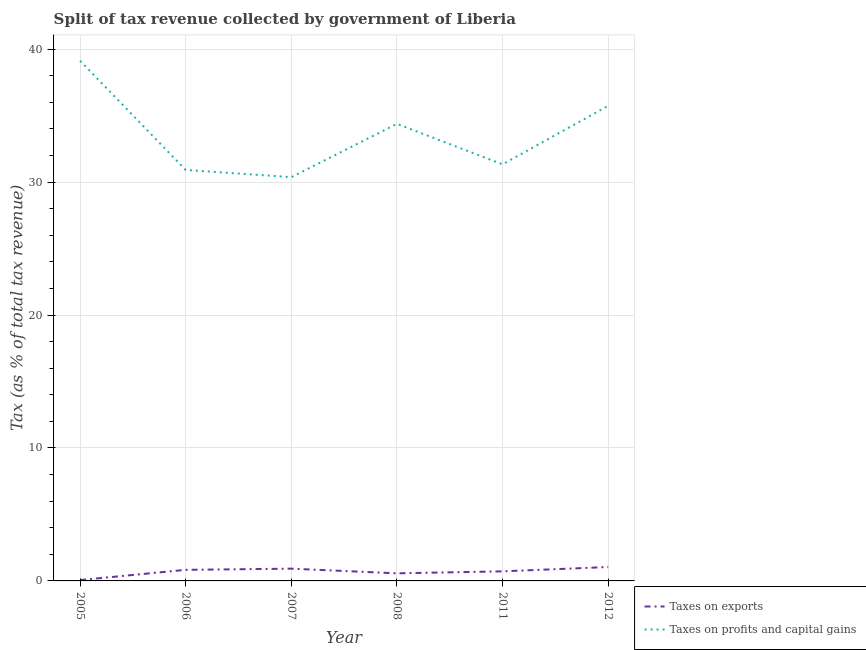How many different coloured lines are there?
Your response must be concise. 2. Is the number of lines equal to the number of legend labels?
Provide a short and direct response. Yes. What is the percentage of revenue obtained from taxes on exports in 2005?
Keep it short and to the point. 0.06. Across all years, what is the maximum percentage of revenue obtained from taxes on exports?
Offer a terse response. 1.05. Across all years, what is the minimum percentage of revenue obtained from taxes on exports?
Make the answer very short. 0.06. In which year was the percentage of revenue obtained from taxes on exports maximum?
Provide a succinct answer. 2012. In which year was the percentage of revenue obtained from taxes on exports minimum?
Ensure brevity in your answer.  2005. What is the total percentage of revenue obtained from taxes on exports in the graph?
Offer a terse response. 4.16. What is the difference between the percentage of revenue obtained from taxes on profits and capital gains in 2008 and that in 2011?
Your answer should be compact. 3.05. What is the difference between the percentage of revenue obtained from taxes on profits and capital gains in 2005 and the percentage of revenue obtained from taxes on exports in 2012?
Offer a very short reply. 38.08. What is the average percentage of revenue obtained from taxes on exports per year?
Your answer should be compact. 0.69. In the year 2005, what is the difference between the percentage of revenue obtained from taxes on profits and capital gains and percentage of revenue obtained from taxes on exports?
Provide a succinct answer. 39.06. What is the ratio of the percentage of revenue obtained from taxes on profits and capital gains in 2007 to that in 2012?
Your answer should be compact. 0.85. Is the percentage of revenue obtained from taxes on exports in 2007 less than that in 2008?
Offer a terse response. No. Is the difference between the percentage of revenue obtained from taxes on profits and capital gains in 2007 and 2011 greater than the difference between the percentage of revenue obtained from taxes on exports in 2007 and 2011?
Provide a short and direct response. No. What is the difference between the highest and the second highest percentage of revenue obtained from taxes on exports?
Ensure brevity in your answer.  0.12. What is the difference between the highest and the lowest percentage of revenue obtained from taxes on exports?
Your response must be concise. 0.98. In how many years, is the percentage of revenue obtained from taxes on profits and capital gains greater than the average percentage of revenue obtained from taxes on profits and capital gains taken over all years?
Offer a terse response. 3. Does the percentage of revenue obtained from taxes on profits and capital gains monotonically increase over the years?
Your answer should be very brief. No. Is the percentage of revenue obtained from taxes on exports strictly greater than the percentage of revenue obtained from taxes on profits and capital gains over the years?
Offer a very short reply. No. Is the percentage of revenue obtained from taxes on profits and capital gains strictly less than the percentage of revenue obtained from taxes on exports over the years?
Offer a very short reply. No. How many lines are there?
Keep it short and to the point. 2. Does the graph contain any zero values?
Provide a succinct answer. No. Does the graph contain grids?
Provide a short and direct response. Yes. Where does the legend appear in the graph?
Ensure brevity in your answer.  Bottom right. How many legend labels are there?
Provide a short and direct response. 2. How are the legend labels stacked?
Offer a very short reply. Vertical. What is the title of the graph?
Provide a succinct answer. Split of tax revenue collected by government of Liberia. Does "% of gross capital formation" appear as one of the legend labels in the graph?
Make the answer very short. No. What is the label or title of the X-axis?
Your answer should be very brief. Year. What is the label or title of the Y-axis?
Provide a succinct answer. Tax (as % of total tax revenue). What is the Tax (as % of total tax revenue) of Taxes on exports in 2005?
Ensure brevity in your answer.  0.06. What is the Tax (as % of total tax revenue) of Taxes on profits and capital gains in 2005?
Your answer should be compact. 39.13. What is the Tax (as % of total tax revenue) in Taxes on exports in 2006?
Your response must be concise. 0.83. What is the Tax (as % of total tax revenue) in Taxes on profits and capital gains in 2006?
Provide a short and direct response. 30.92. What is the Tax (as % of total tax revenue) in Taxes on exports in 2007?
Provide a succinct answer. 0.92. What is the Tax (as % of total tax revenue) in Taxes on profits and capital gains in 2007?
Make the answer very short. 30.38. What is the Tax (as % of total tax revenue) of Taxes on exports in 2008?
Your answer should be very brief. 0.57. What is the Tax (as % of total tax revenue) in Taxes on profits and capital gains in 2008?
Provide a short and direct response. 34.38. What is the Tax (as % of total tax revenue) of Taxes on exports in 2011?
Your answer should be compact. 0.72. What is the Tax (as % of total tax revenue) in Taxes on profits and capital gains in 2011?
Your answer should be very brief. 31.34. What is the Tax (as % of total tax revenue) in Taxes on exports in 2012?
Offer a terse response. 1.05. What is the Tax (as % of total tax revenue) in Taxes on profits and capital gains in 2012?
Offer a very short reply. 35.74. Across all years, what is the maximum Tax (as % of total tax revenue) in Taxes on exports?
Make the answer very short. 1.05. Across all years, what is the maximum Tax (as % of total tax revenue) in Taxes on profits and capital gains?
Provide a succinct answer. 39.13. Across all years, what is the minimum Tax (as % of total tax revenue) in Taxes on exports?
Provide a succinct answer. 0.06. Across all years, what is the minimum Tax (as % of total tax revenue) in Taxes on profits and capital gains?
Offer a terse response. 30.38. What is the total Tax (as % of total tax revenue) of Taxes on exports in the graph?
Keep it short and to the point. 4.16. What is the total Tax (as % of total tax revenue) of Taxes on profits and capital gains in the graph?
Keep it short and to the point. 201.89. What is the difference between the Tax (as % of total tax revenue) in Taxes on exports in 2005 and that in 2006?
Give a very brief answer. -0.77. What is the difference between the Tax (as % of total tax revenue) of Taxes on profits and capital gains in 2005 and that in 2006?
Make the answer very short. 8.21. What is the difference between the Tax (as % of total tax revenue) of Taxes on exports in 2005 and that in 2007?
Provide a succinct answer. -0.86. What is the difference between the Tax (as % of total tax revenue) of Taxes on profits and capital gains in 2005 and that in 2007?
Keep it short and to the point. 8.75. What is the difference between the Tax (as % of total tax revenue) of Taxes on exports in 2005 and that in 2008?
Offer a terse response. -0.51. What is the difference between the Tax (as % of total tax revenue) in Taxes on profits and capital gains in 2005 and that in 2008?
Provide a succinct answer. 4.74. What is the difference between the Tax (as % of total tax revenue) in Taxes on exports in 2005 and that in 2011?
Make the answer very short. -0.66. What is the difference between the Tax (as % of total tax revenue) of Taxes on profits and capital gains in 2005 and that in 2011?
Offer a very short reply. 7.79. What is the difference between the Tax (as % of total tax revenue) of Taxes on exports in 2005 and that in 2012?
Your answer should be very brief. -0.98. What is the difference between the Tax (as % of total tax revenue) of Taxes on profits and capital gains in 2005 and that in 2012?
Ensure brevity in your answer.  3.38. What is the difference between the Tax (as % of total tax revenue) in Taxes on exports in 2006 and that in 2007?
Your response must be concise. -0.09. What is the difference between the Tax (as % of total tax revenue) in Taxes on profits and capital gains in 2006 and that in 2007?
Provide a short and direct response. 0.54. What is the difference between the Tax (as % of total tax revenue) of Taxes on exports in 2006 and that in 2008?
Ensure brevity in your answer.  0.26. What is the difference between the Tax (as % of total tax revenue) in Taxes on profits and capital gains in 2006 and that in 2008?
Ensure brevity in your answer.  -3.47. What is the difference between the Tax (as % of total tax revenue) of Taxes on exports in 2006 and that in 2011?
Provide a short and direct response. 0.11. What is the difference between the Tax (as % of total tax revenue) in Taxes on profits and capital gains in 2006 and that in 2011?
Your response must be concise. -0.42. What is the difference between the Tax (as % of total tax revenue) in Taxes on exports in 2006 and that in 2012?
Make the answer very short. -0.21. What is the difference between the Tax (as % of total tax revenue) in Taxes on profits and capital gains in 2006 and that in 2012?
Your response must be concise. -4.83. What is the difference between the Tax (as % of total tax revenue) in Taxes on exports in 2007 and that in 2008?
Keep it short and to the point. 0.35. What is the difference between the Tax (as % of total tax revenue) of Taxes on profits and capital gains in 2007 and that in 2008?
Keep it short and to the point. -4.01. What is the difference between the Tax (as % of total tax revenue) of Taxes on exports in 2007 and that in 2011?
Your response must be concise. 0.2. What is the difference between the Tax (as % of total tax revenue) of Taxes on profits and capital gains in 2007 and that in 2011?
Offer a terse response. -0.96. What is the difference between the Tax (as % of total tax revenue) in Taxes on exports in 2007 and that in 2012?
Provide a short and direct response. -0.12. What is the difference between the Tax (as % of total tax revenue) of Taxes on profits and capital gains in 2007 and that in 2012?
Make the answer very short. -5.37. What is the difference between the Tax (as % of total tax revenue) of Taxes on exports in 2008 and that in 2011?
Keep it short and to the point. -0.15. What is the difference between the Tax (as % of total tax revenue) of Taxes on profits and capital gains in 2008 and that in 2011?
Give a very brief answer. 3.05. What is the difference between the Tax (as % of total tax revenue) of Taxes on exports in 2008 and that in 2012?
Give a very brief answer. -0.47. What is the difference between the Tax (as % of total tax revenue) in Taxes on profits and capital gains in 2008 and that in 2012?
Make the answer very short. -1.36. What is the difference between the Tax (as % of total tax revenue) in Taxes on exports in 2011 and that in 2012?
Ensure brevity in your answer.  -0.33. What is the difference between the Tax (as % of total tax revenue) of Taxes on profits and capital gains in 2011 and that in 2012?
Your response must be concise. -4.41. What is the difference between the Tax (as % of total tax revenue) in Taxes on exports in 2005 and the Tax (as % of total tax revenue) in Taxes on profits and capital gains in 2006?
Your response must be concise. -30.85. What is the difference between the Tax (as % of total tax revenue) in Taxes on exports in 2005 and the Tax (as % of total tax revenue) in Taxes on profits and capital gains in 2007?
Make the answer very short. -30.31. What is the difference between the Tax (as % of total tax revenue) of Taxes on exports in 2005 and the Tax (as % of total tax revenue) of Taxes on profits and capital gains in 2008?
Offer a terse response. -34.32. What is the difference between the Tax (as % of total tax revenue) of Taxes on exports in 2005 and the Tax (as % of total tax revenue) of Taxes on profits and capital gains in 2011?
Offer a very short reply. -31.27. What is the difference between the Tax (as % of total tax revenue) in Taxes on exports in 2005 and the Tax (as % of total tax revenue) in Taxes on profits and capital gains in 2012?
Offer a very short reply. -35.68. What is the difference between the Tax (as % of total tax revenue) in Taxes on exports in 2006 and the Tax (as % of total tax revenue) in Taxes on profits and capital gains in 2007?
Your answer should be compact. -29.54. What is the difference between the Tax (as % of total tax revenue) of Taxes on exports in 2006 and the Tax (as % of total tax revenue) of Taxes on profits and capital gains in 2008?
Provide a short and direct response. -33.55. What is the difference between the Tax (as % of total tax revenue) in Taxes on exports in 2006 and the Tax (as % of total tax revenue) in Taxes on profits and capital gains in 2011?
Your response must be concise. -30.5. What is the difference between the Tax (as % of total tax revenue) of Taxes on exports in 2006 and the Tax (as % of total tax revenue) of Taxes on profits and capital gains in 2012?
Give a very brief answer. -34.91. What is the difference between the Tax (as % of total tax revenue) in Taxes on exports in 2007 and the Tax (as % of total tax revenue) in Taxes on profits and capital gains in 2008?
Ensure brevity in your answer.  -33.46. What is the difference between the Tax (as % of total tax revenue) of Taxes on exports in 2007 and the Tax (as % of total tax revenue) of Taxes on profits and capital gains in 2011?
Provide a short and direct response. -30.42. What is the difference between the Tax (as % of total tax revenue) in Taxes on exports in 2007 and the Tax (as % of total tax revenue) in Taxes on profits and capital gains in 2012?
Give a very brief answer. -34.82. What is the difference between the Tax (as % of total tax revenue) in Taxes on exports in 2008 and the Tax (as % of total tax revenue) in Taxes on profits and capital gains in 2011?
Give a very brief answer. -30.77. What is the difference between the Tax (as % of total tax revenue) of Taxes on exports in 2008 and the Tax (as % of total tax revenue) of Taxes on profits and capital gains in 2012?
Give a very brief answer. -35.17. What is the difference between the Tax (as % of total tax revenue) in Taxes on exports in 2011 and the Tax (as % of total tax revenue) in Taxes on profits and capital gains in 2012?
Your response must be concise. -35.02. What is the average Tax (as % of total tax revenue) in Taxes on exports per year?
Your answer should be compact. 0.69. What is the average Tax (as % of total tax revenue) of Taxes on profits and capital gains per year?
Your answer should be compact. 33.65. In the year 2005, what is the difference between the Tax (as % of total tax revenue) of Taxes on exports and Tax (as % of total tax revenue) of Taxes on profits and capital gains?
Your answer should be very brief. -39.06. In the year 2006, what is the difference between the Tax (as % of total tax revenue) in Taxes on exports and Tax (as % of total tax revenue) in Taxes on profits and capital gains?
Keep it short and to the point. -30.08. In the year 2007, what is the difference between the Tax (as % of total tax revenue) in Taxes on exports and Tax (as % of total tax revenue) in Taxes on profits and capital gains?
Offer a very short reply. -29.45. In the year 2008, what is the difference between the Tax (as % of total tax revenue) of Taxes on exports and Tax (as % of total tax revenue) of Taxes on profits and capital gains?
Make the answer very short. -33.81. In the year 2011, what is the difference between the Tax (as % of total tax revenue) in Taxes on exports and Tax (as % of total tax revenue) in Taxes on profits and capital gains?
Your response must be concise. -30.62. In the year 2012, what is the difference between the Tax (as % of total tax revenue) in Taxes on exports and Tax (as % of total tax revenue) in Taxes on profits and capital gains?
Offer a terse response. -34.7. What is the ratio of the Tax (as % of total tax revenue) in Taxes on exports in 2005 to that in 2006?
Give a very brief answer. 0.08. What is the ratio of the Tax (as % of total tax revenue) in Taxes on profits and capital gains in 2005 to that in 2006?
Keep it short and to the point. 1.27. What is the ratio of the Tax (as % of total tax revenue) in Taxes on exports in 2005 to that in 2007?
Offer a very short reply. 0.07. What is the ratio of the Tax (as % of total tax revenue) of Taxes on profits and capital gains in 2005 to that in 2007?
Provide a short and direct response. 1.29. What is the ratio of the Tax (as % of total tax revenue) of Taxes on exports in 2005 to that in 2008?
Offer a very short reply. 0.11. What is the ratio of the Tax (as % of total tax revenue) in Taxes on profits and capital gains in 2005 to that in 2008?
Make the answer very short. 1.14. What is the ratio of the Tax (as % of total tax revenue) of Taxes on exports in 2005 to that in 2011?
Make the answer very short. 0.09. What is the ratio of the Tax (as % of total tax revenue) in Taxes on profits and capital gains in 2005 to that in 2011?
Your response must be concise. 1.25. What is the ratio of the Tax (as % of total tax revenue) of Taxes on exports in 2005 to that in 2012?
Offer a terse response. 0.06. What is the ratio of the Tax (as % of total tax revenue) of Taxes on profits and capital gains in 2005 to that in 2012?
Your answer should be very brief. 1.09. What is the ratio of the Tax (as % of total tax revenue) of Taxes on exports in 2006 to that in 2007?
Provide a succinct answer. 0.9. What is the ratio of the Tax (as % of total tax revenue) in Taxes on profits and capital gains in 2006 to that in 2007?
Give a very brief answer. 1.02. What is the ratio of the Tax (as % of total tax revenue) in Taxes on exports in 2006 to that in 2008?
Make the answer very short. 1.46. What is the ratio of the Tax (as % of total tax revenue) of Taxes on profits and capital gains in 2006 to that in 2008?
Make the answer very short. 0.9. What is the ratio of the Tax (as % of total tax revenue) in Taxes on exports in 2006 to that in 2011?
Make the answer very short. 1.16. What is the ratio of the Tax (as % of total tax revenue) of Taxes on profits and capital gains in 2006 to that in 2011?
Make the answer very short. 0.99. What is the ratio of the Tax (as % of total tax revenue) in Taxes on exports in 2006 to that in 2012?
Offer a terse response. 0.8. What is the ratio of the Tax (as % of total tax revenue) in Taxes on profits and capital gains in 2006 to that in 2012?
Your answer should be very brief. 0.86. What is the ratio of the Tax (as % of total tax revenue) of Taxes on exports in 2007 to that in 2008?
Your answer should be very brief. 1.61. What is the ratio of the Tax (as % of total tax revenue) in Taxes on profits and capital gains in 2007 to that in 2008?
Your answer should be compact. 0.88. What is the ratio of the Tax (as % of total tax revenue) in Taxes on exports in 2007 to that in 2011?
Provide a short and direct response. 1.28. What is the ratio of the Tax (as % of total tax revenue) in Taxes on profits and capital gains in 2007 to that in 2011?
Provide a short and direct response. 0.97. What is the ratio of the Tax (as % of total tax revenue) in Taxes on exports in 2007 to that in 2012?
Offer a terse response. 0.88. What is the ratio of the Tax (as % of total tax revenue) in Taxes on profits and capital gains in 2007 to that in 2012?
Your answer should be compact. 0.85. What is the ratio of the Tax (as % of total tax revenue) in Taxes on exports in 2008 to that in 2011?
Ensure brevity in your answer.  0.79. What is the ratio of the Tax (as % of total tax revenue) in Taxes on profits and capital gains in 2008 to that in 2011?
Ensure brevity in your answer.  1.1. What is the ratio of the Tax (as % of total tax revenue) in Taxes on exports in 2008 to that in 2012?
Make the answer very short. 0.55. What is the ratio of the Tax (as % of total tax revenue) in Taxes on profits and capital gains in 2008 to that in 2012?
Provide a succinct answer. 0.96. What is the ratio of the Tax (as % of total tax revenue) in Taxes on exports in 2011 to that in 2012?
Give a very brief answer. 0.69. What is the ratio of the Tax (as % of total tax revenue) of Taxes on profits and capital gains in 2011 to that in 2012?
Keep it short and to the point. 0.88. What is the difference between the highest and the second highest Tax (as % of total tax revenue) in Taxes on exports?
Make the answer very short. 0.12. What is the difference between the highest and the second highest Tax (as % of total tax revenue) of Taxes on profits and capital gains?
Ensure brevity in your answer.  3.38. What is the difference between the highest and the lowest Tax (as % of total tax revenue) of Taxes on exports?
Give a very brief answer. 0.98. What is the difference between the highest and the lowest Tax (as % of total tax revenue) of Taxes on profits and capital gains?
Give a very brief answer. 8.75. 